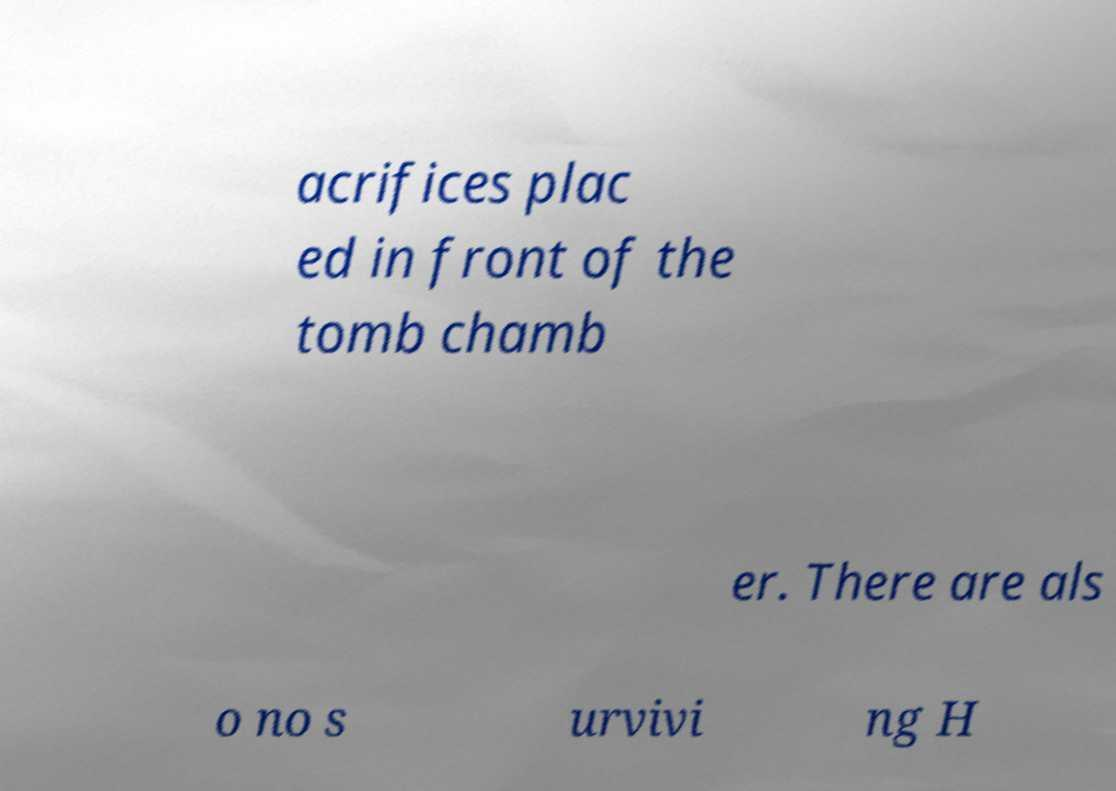Can you read and provide the text displayed in the image?This photo seems to have some interesting text. Can you extract and type it out for me? acrifices plac ed in front of the tomb chamb er. There are als o no s urvivi ng H 